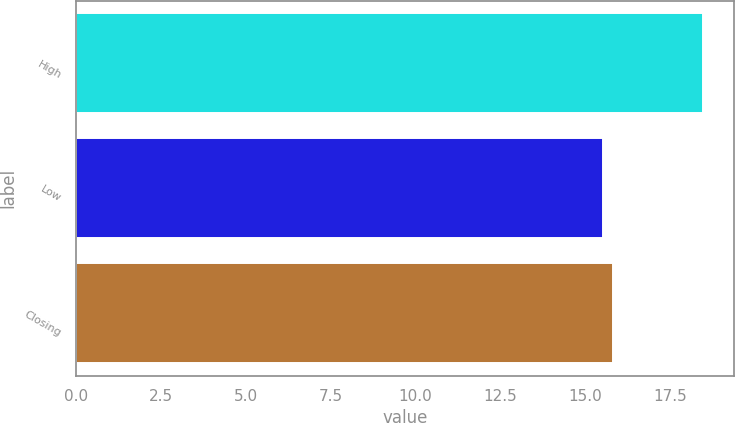<chart> <loc_0><loc_0><loc_500><loc_500><bar_chart><fcel>High<fcel>Low<fcel>Closing<nl><fcel>18.46<fcel>15.53<fcel>15.82<nl></chart> 